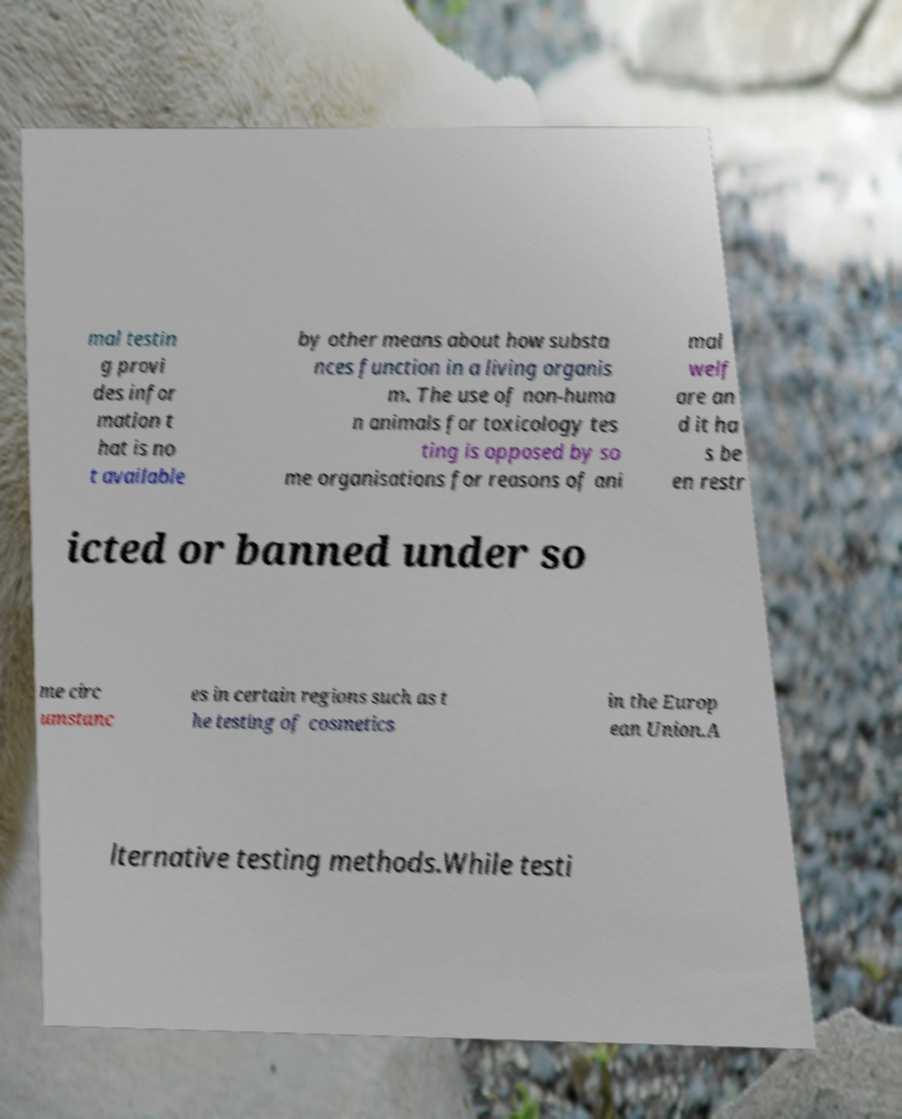What messages or text are displayed in this image? I need them in a readable, typed format. mal testin g provi des infor mation t hat is no t available by other means about how substa nces function in a living organis m. The use of non-huma n animals for toxicology tes ting is opposed by so me organisations for reasons of ani mal welf are an d it ha s be en restr icted or banned under so me circ umstanc es in certain regions such as t he testing of cosmetics in the Europ ean Union.A lternative testing methods.While testi 